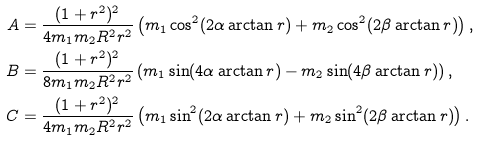<formula> <loc_0><loc_0><loc_500><loc_500>A & = \frac { ( 1 + r ^ { 2 } ) ^ { 2 } } { 4 m _ { 1 } m _ { 2 } R ^ { 2 } r ^ { 2 } } \left ( m _ { 1 } \cos ^ { 2 } ( 2 \alpha \arctan r ) + m _ { 2 } \cos ^ { 2 } ( 2 \beta \arctan r ) \right ) , \\ B & = \frac { ( 1 + r ^ { 2 } ) ^ { 2 } } { 8 m _ { 1 } m _ { 2 } R ^ { 2 } r ^ { 2 } } \left ( m _ { 1 } \sin ( 4 \alpha \arctan r ) - m _ { 2 } \sin ( 4 \beta \arctan r ) \right ) , \\ C & = \frac { ( 1 + r ^ { 2 } ) ^ { 2 } } { 4 m _ { 1 } m _ { 2 } R ^ { 2 } r ^ { 2 } } \left ( m _ { 1 } \sin ^ { 2 } ( 2 \alpha \arctan r ) + m _ { 2 } \sin ^ { 2 } ( 2 \beta \arctan r ) \right ) .</formula> 